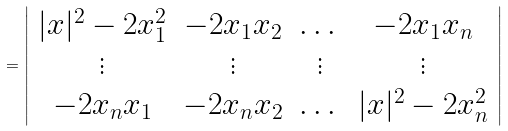Convert formula to latex. <formula><loc_0><loc_0><loc_500><loc_500>= \left | \begin{array} { c c c c } | x | ^ { 2 } - 2 x _ { 1 } ^ { 2 } & - 2 x _ { 1 } x _ { 2 } & \dots & - 2 x _ { 1 } x _ { n } \\ \vdots & \vdots & \vdots & \vdots \\ - 2 x _ { n } x _ { 1 } & - 2 x _ { n } x _ { 2 } & \dots & | x | ^ { 2 } - 2 x _ { n } ^ { 2 } \end{array} \right |</formula> 